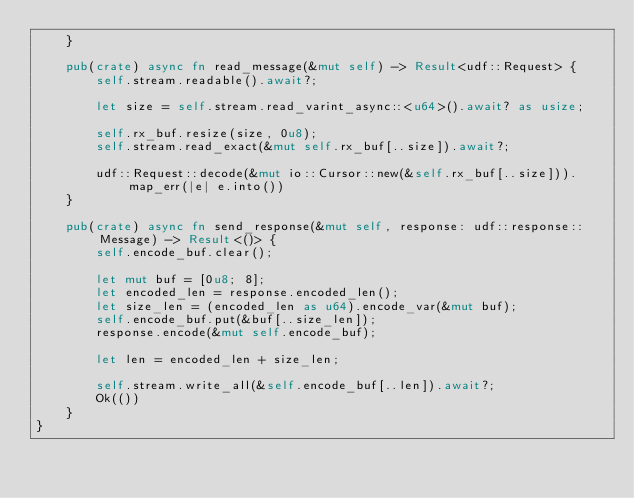Convert code to text. <code><loc_0><loc_0><loc_500><loc_500><_Rust_>    }

    pub(crate) async fn read_message(&mut self) -> Result<udf::Request> {
        self.stream.readable().await?;

        let size = self.stream.read_varint_async::<u64>().await? as usize;

        self.rx_buf.resize(size, 0u8);
        self.stream.read_exact(&mut self.rx_buf[..size]).await?;

        udf::Request::decode(&mut io::Cursor::new(&self.rx_buf[..size])).map_err(|e| e.into())
    }

    pub(crate) async fn send_response(&mut self, response: udf::response::Message) -> Result<()> {
        self.encode_buf.clear();

        let mut buf = [0u8; 8];
        let encoded_len = response.encoded_len();
        let size_len = (encoded_len as u64).encode_var(&mut buf);
        self.encode_buf.put(&buf[..size_len]);
        response.encode(&mut self.encode_buf);

        let len = encoded_len + size_len;

        self.stream.write_all(&self.encode_buf[..len]).await?;
        Ok(())
    }
}
</code> 